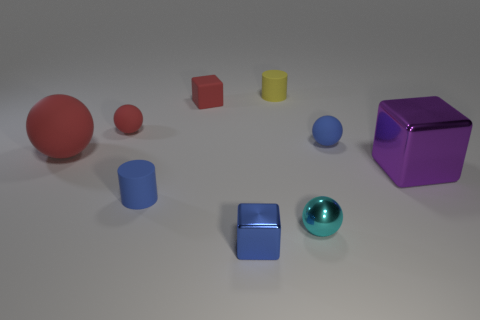There is a matte block that is the same color as the big matte object; what is its size?
Provide a short and direct response. Small. There is a large object that is the same color as the matte cube; what is it made of?
Offer a terse response. Rubber. Do the ball that is on the right side of the small cyan sphere and the large red ball have the same material?
Your answer should be very brief. Yes. What is the shape of the cyan metal thing that is the same size as the yellow cylinder?
Provide a short and direct response. Sphere. What number of large metal blocks have the same color as the big rubber object?
Ensure brevity in your answer.  0. Are there fewer small blue rubber balls in front of the blue block than tiny metal balls that are in front of the large purple object?
Your answer should be compact. Yes. There is a cyan sphere; are there any large purple metallic cubes to the right of it?
Offer a very short reply. Yes. Are there any matte cubes that are in front of the small rubber thing that is right of the small cylinder behind the large red ball?
Offer a terse response. No. There is a blue matte thing that is right of the shiny sphere; is it the same shape as the small cyan object?
Ensure brevity in your answer.  Yes. There is another small cube that is made of the same material as the purple cube; what color is it?
Make the answer very short. Blue. 